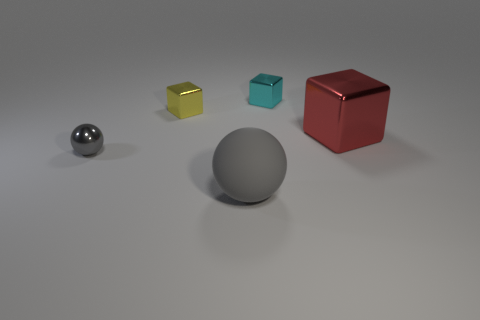Subtract all purple blocks. Subtract all purple balls. How many blocks are left? 3 Add 4 green balls. How many objects exist? 9 Subtract all balls. How many objects are left? 3 Subtract 0 brown blocks. How many objects are left? 5 Subtract all purple metal spheres. Subtract all yellow things. How many objects are left? 4 Add 4 tiny gray metallic things. How many tiny gray metallic things are left? 5 Add 1 small green rubber blocks. How many small green rubber blocks exist? 1 